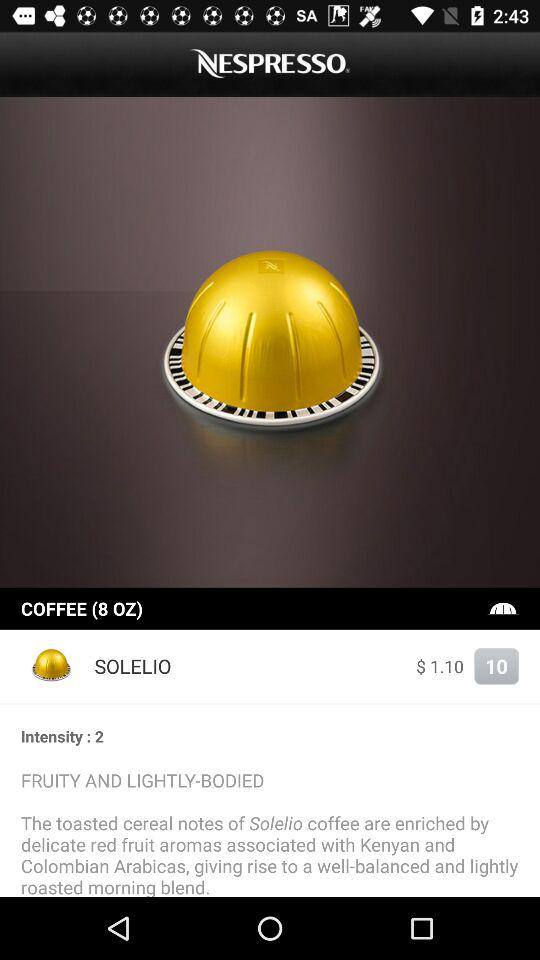What is the quantity of coffee? The quantity of coffee is 8 oz. 